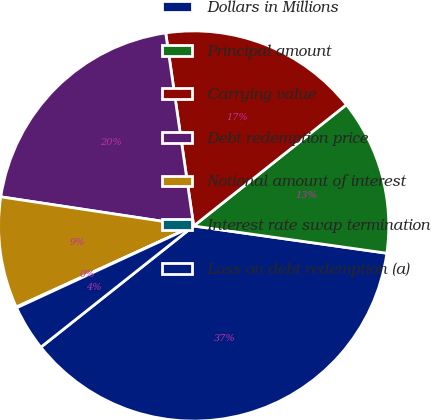Convert chart. <chart><loc_0><loc_0><loc_500><loc_500><pie_chart><fcel>Dollars in Millions<fcel>Principal amount<fcel>Carrying value<fcel>Debt redemption price<fcel>Notional amount of interest<fcel>Interest rate swap termination<fcel>Loss on debt redemption (a)<nl><fcel>37.1%<fcel>12.91%<fcel>16.61%<fcel>20.32%<fcel>9.21%<fcel>0.07%<fcel>3.78%<nl></chart> 